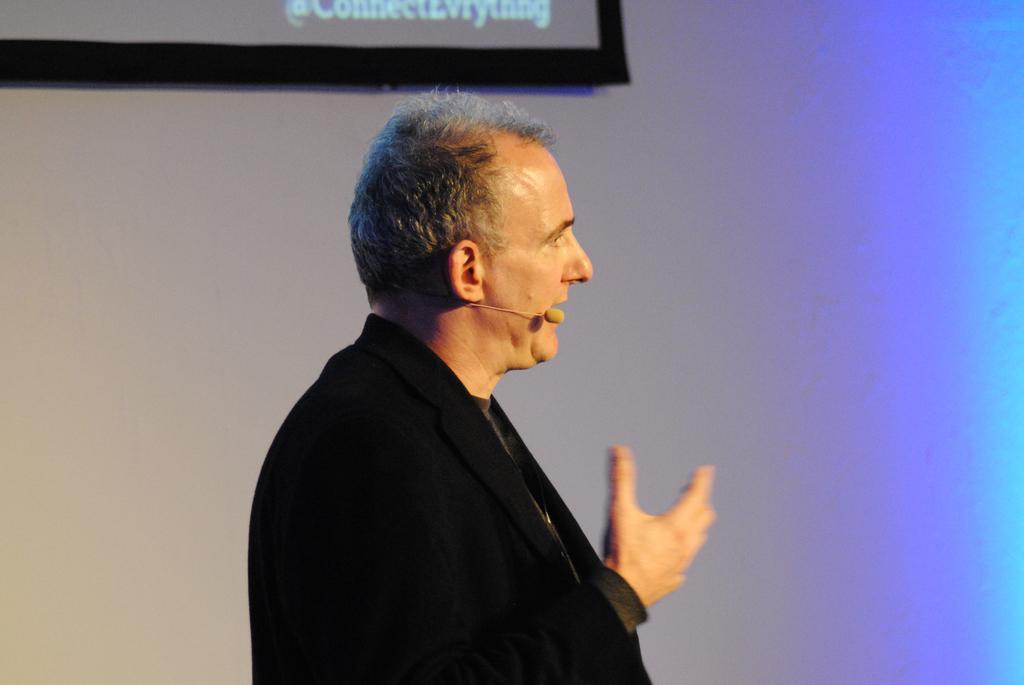Can you describe this image briefly? In the center of the image there is a person wearing a black color suit and a mic. In the background of the image there is wall. 